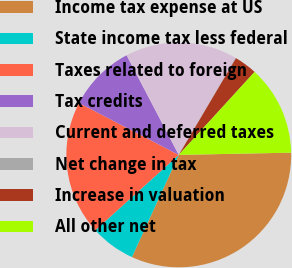<chart> <loc_0><loc_0><loc_500><loc_500><pie_chart><fcel>Income tax expense at US<fcel>State income tax less federal<fcel>Taxes related to foreign<fcel>Tax credits<fcel>Current and deferred taxes<fcel>Net change in tax<fcel>Increase in valuation<fcel>All other net<nl><fcel>32.15%<fcel>6.48%<fcel>19.32%<fcel>9.69%<fcel>16.11%<fcel>0.07%<fcel>3.28%<fcel>12.9%<nl></chart> 